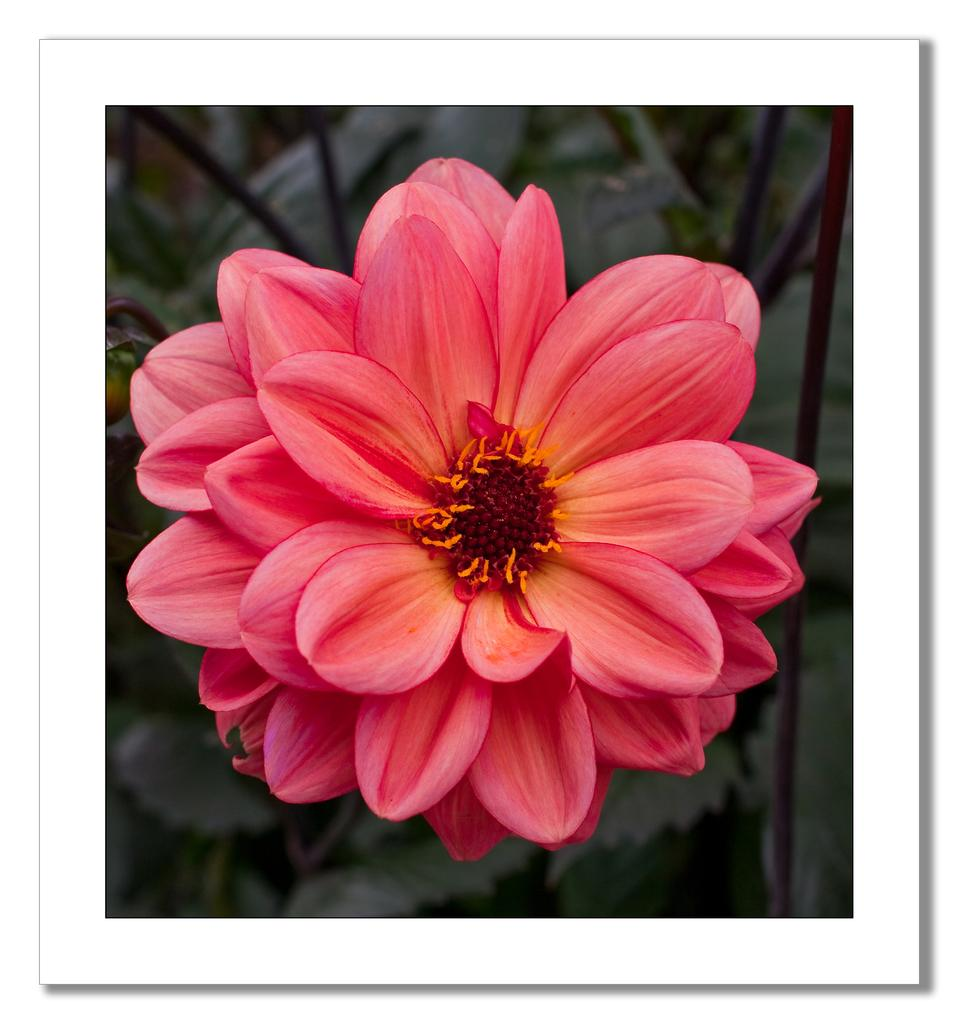What is the main subject of the image? There is a flower in the image. What can be seen in the background of the image? There are leaves visible in the background of the image. What type of plastic material is used to make the berry in the image? There is no berry present in the image, and therefore no plastic material is used to make it. 